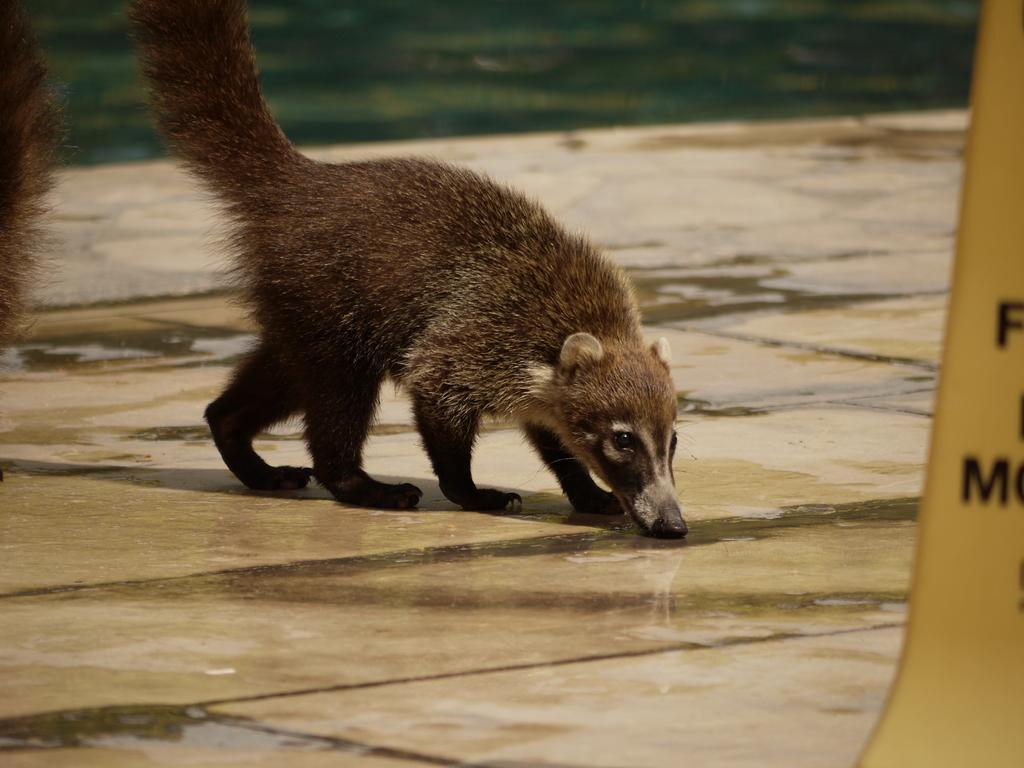Can you describe this image briefly? In this picture we can observe an animal which is in brown color on the floor. On the left right we can observe another animal. We can observe some water on the floor. 